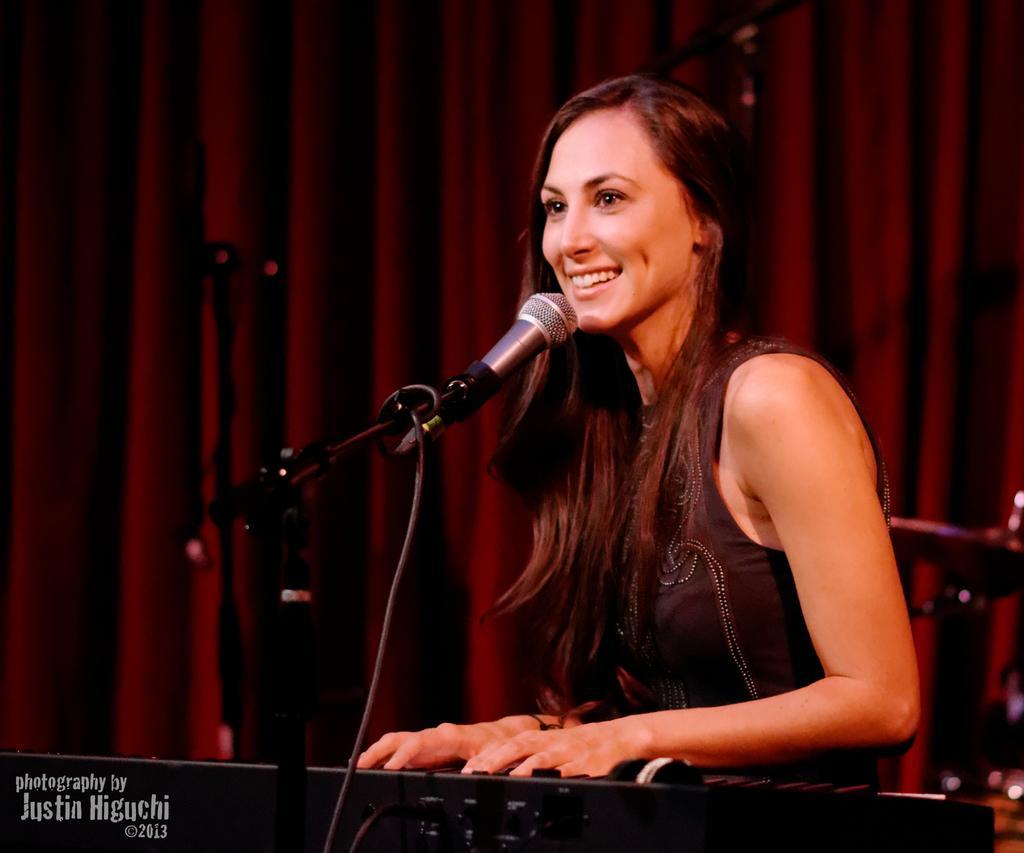How would you summarize this image in a sentence or two? In the picture there is a woman, she is playing a piano and in front of the piano there is a mic, the woman is laughing and in the background there is a curtain. 